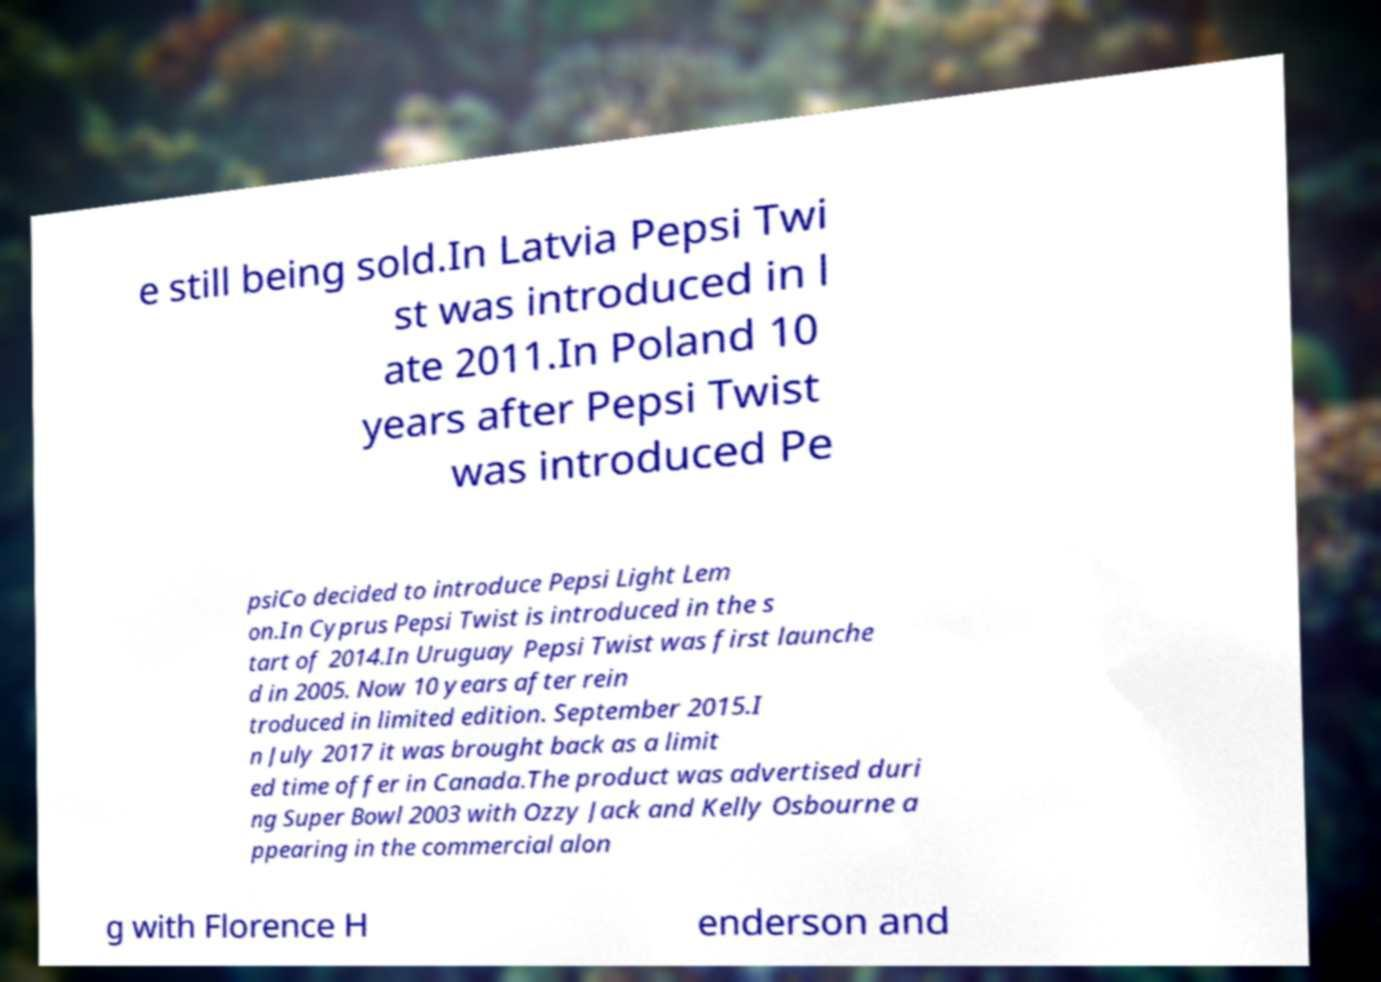Please identify and transcribe the text found in this image. e still being sold.In Latvia Pepsi Twi st was introduced in l ate 2011.In Poland 10 years after Pepsi Twist was introduced Pe psiCo decided to introduce Pepsi Light Lem on.In Cyprus Pepsi Twist is introduced in the s tart of 2014.In Uruguay Pepsi Twist was first launche d in 2005. Now 10 years after rein troduced in limited edition. September 2015.I n July 2017 it was brought back as a limit ed time offer in Canada.The product was advertised duri ng Super Bowl 2003 with Ozzy Jack and Kelly Osbourne a ppearing in the commercial alon g with Florence H enderson and 